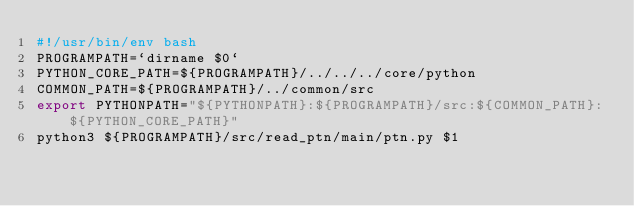Convert code to text. <code><loc_0><loc_0><loc_500><loc_500><_Bash_>#!/usr/bin/env bash
PROGRAMPATH=`dirname $0`
PYTHON_CORE_PATH=${PROGRAMPATH}/../../../core/python
COMMON_PATH=${PROGRAMPATH}/../common/src
export PYTHONPATH="${PYTHONPATH}:${PROGRAMPATH}/src:${COMMON_PATH}:${PYTHON_CORE_PATH}"
python3 ${PROGRAMPATH}/src/read_ptn/main/ptn.py $1</code> 